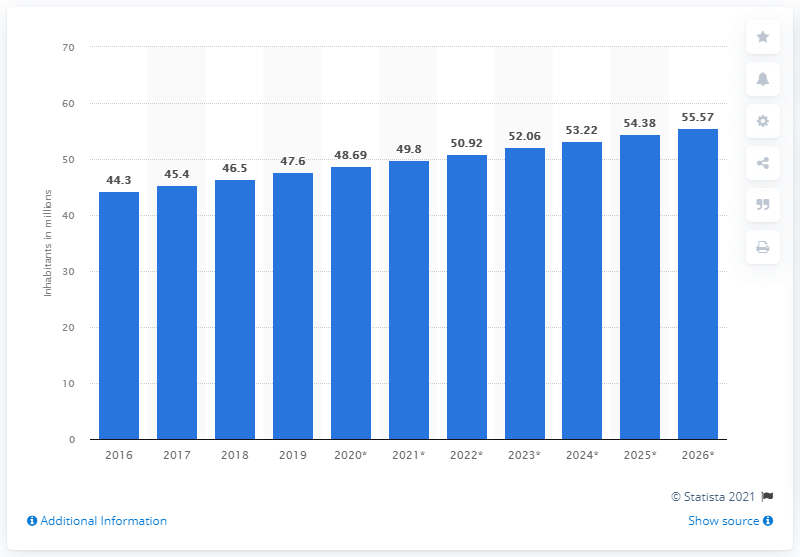Highlight a few significant elements in this photo. In 2019, the population of Kenya was 47.6 million people. 